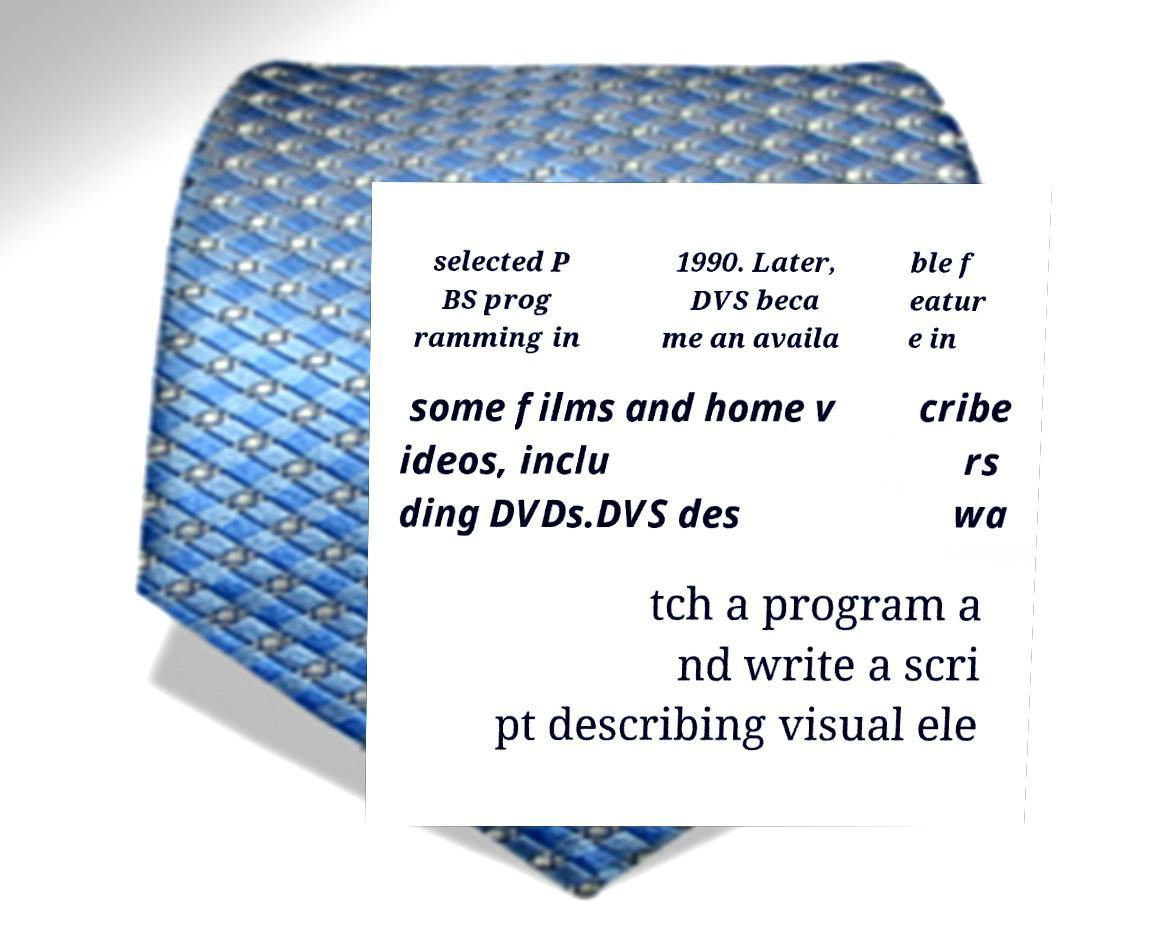What messages or text are displayed in this image? I need them in a readable, typed format. selected P BS prog ramming in 1990. Later, DVS beca me an availa ble f eatur e in some films and home v ideos, inclu ding DVDs.DVS des cribe rs wa tch a program a nd write a scri pt describing visual ele 